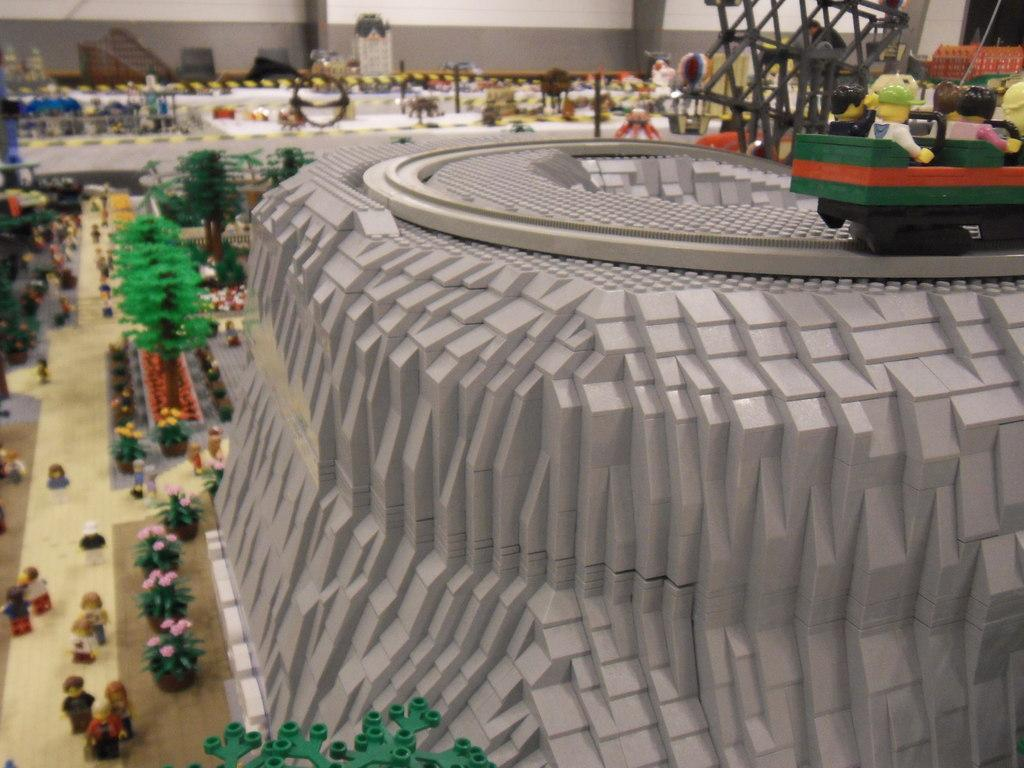What is the main subject of the image? The main subject of the image is a scale model of a town. What material is used to create the scale model? The scale model is made with Lego toys. Can you describe the people in the image? There are people on the road on the left side of the image. What type of natural elements can be seen in the image? There are trees visible in the image. What type of pest can be seen crawling on the Lego trees in the image? There are no pests visible in the image, as it features a scale model of a town made with Lego toys. How many cups of coffee are being consumed by the family in the image? There is no family present in the image, nor any cups of coffee. 